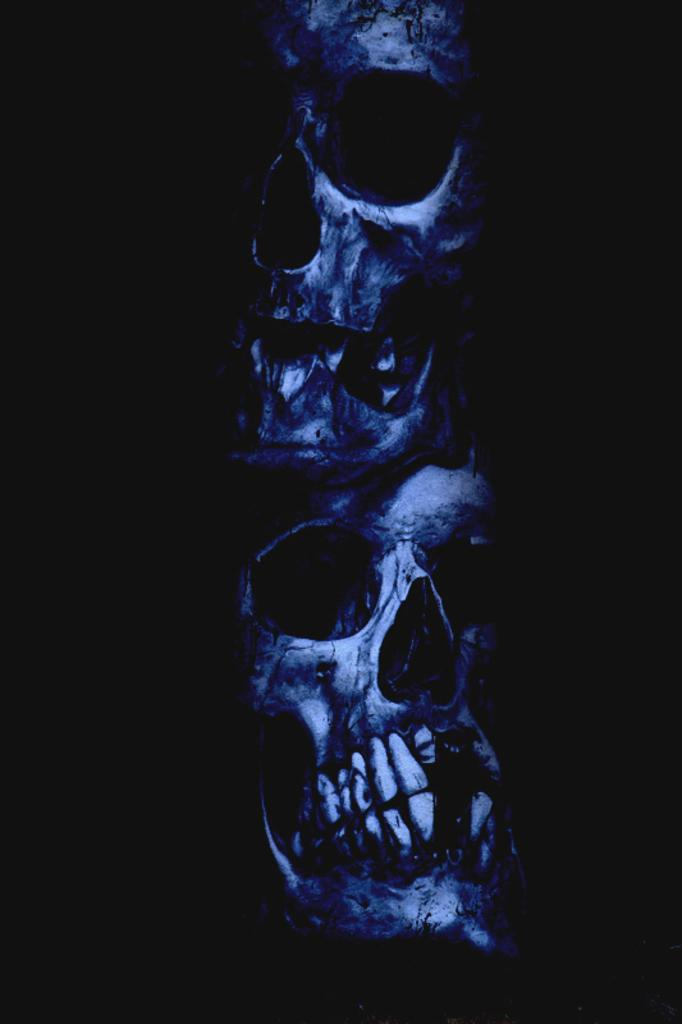What objects are present in the image? There are skulls in the image. What is the color of the background in the image? The background of the image is dark. What type of copper material can be seen in the image? There is no copper material present in the image. What is the noise level in the image? The noise level cannot be determined from the image, as it is a still image and does not convey sound. 